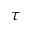<formula> <loc_0><loc_0><loc_500><loc_500>\tau</formula> 